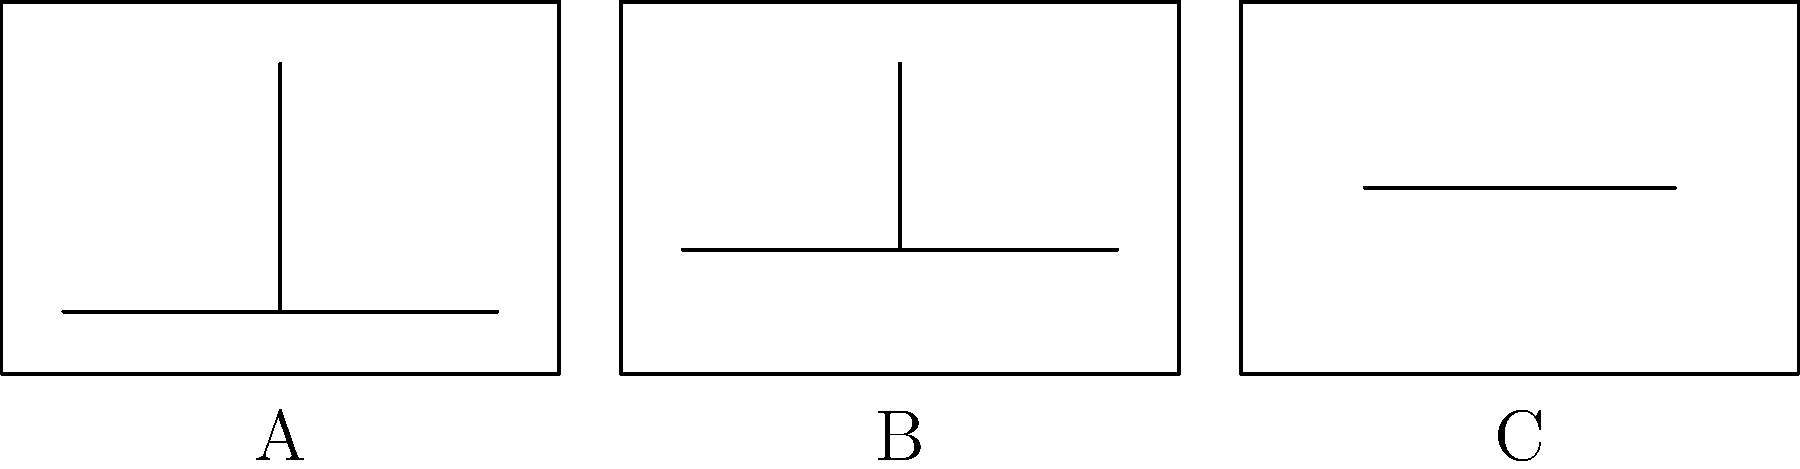In the storyboard above, which shot composition technique is represented by frame C? To answer this question, let's analyze the three frames in the storyboard:

1. Frame A: This frame shows a full horizontal line at the bottom and a vertical line extending from it. This represents a wide shot, capturing a broad view of the scene.

2. Frame B: This frame has a slightly shorter horizontal line positioned higher than in frame A, with a vertical line of similar height. This represents a medium shot, which typically frames the subject from the waist up.

3. Frame C: This frame contains only a short horizontal line positioned even higher in the frame. This represents a close-up shot, which focuses on a small area or detail, such as a character's face.

The question asks specifically about frame C. The short line positioned high in the frame indicates that we are seeing a very limited portion of the scene, which is characteristic of a close-up shot.

Close-up shots are used to show detail, emphasize emotions, or highlight important elements in a scene. They bring the viewer's attention to specific aspects of the subject that might not be as noticeable in wider shots.
Answer: Close-up shot 